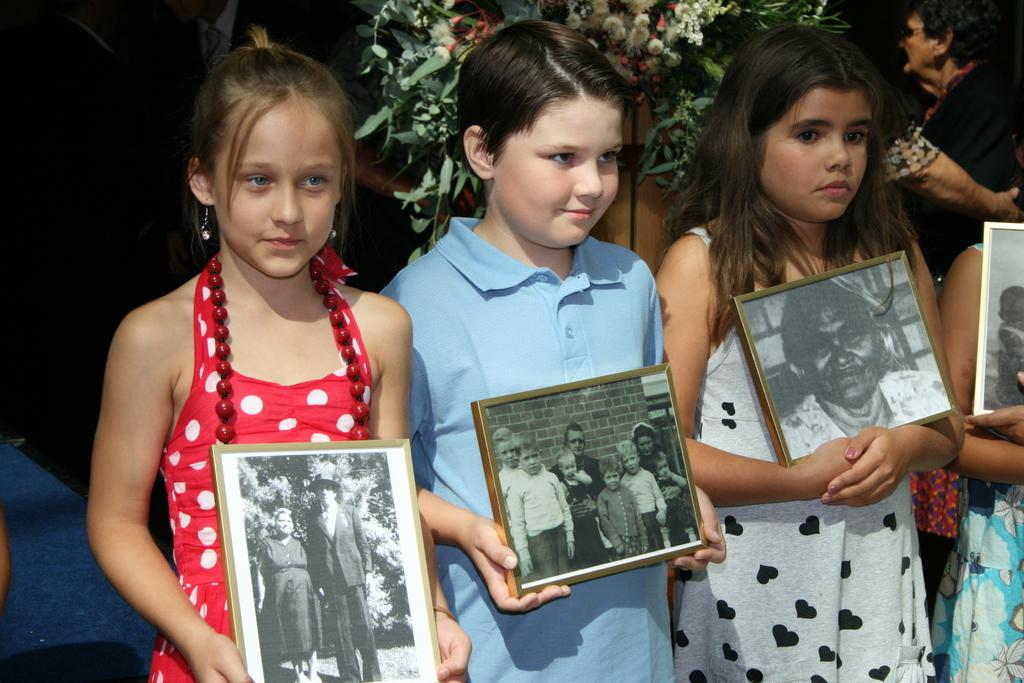What are the kids holding in the image? The kids are holding photo frames in the image. What can be seen in the background of the image? There are flower plants and persons in the background of the image. Are there any other objects visible in the background? Yes, there are other objects in the background of the image. What type of feast is being prepared in the image? There is no feast being prepared in the image; it features kids holding photo frames and a background with flower plants, persons, and other objects. What thoughts are the kids having while holding the photo frames in the image? The thoughts of the kids cannot be determined from the image, as it only shows them holding photo frames and does not provide any insight into their thoughts or emotions. 